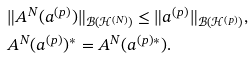<formula> <loc_0><loc_0><loc_500><loc_500>& \| A ^ { N } ( a ^ { ( p ) } ) \| _ { { \mathcal { B } } ( { \mathcal { H } } ^ { ( N ) } ) } \leq \| a ^ { ( p ) } \| _ { { \mathcal { B } } ( { \mathcal { H } } ^ { ( p ) } ) } , \\ & A ^ { N } ( a ^ { ( p ) } ) ^ { * } = A ^ { N } ( a ^ { ( p ) * } ) .</formula> 